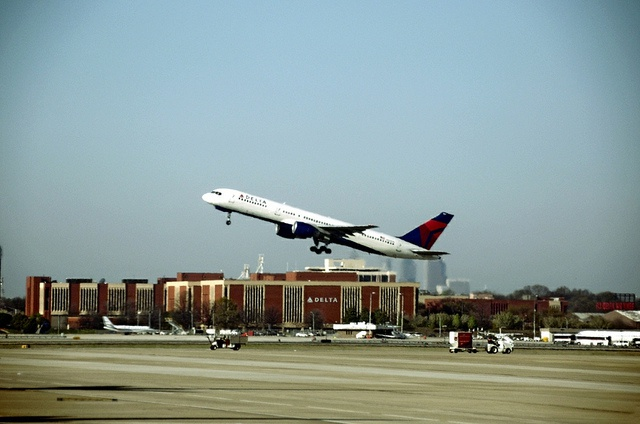Describe the objects in this image and their specific colors. I can see airplane in teal, white, black, darkgray, and gray tones, truck in teal, black, ivory, gray, and darkgray tones, airplane in teal, white, black, gray, and darkgray tones, airplane in teal, white, darkgray, gray, and black tones, and car in teal, ivory, darkgray, gray, and darkgreen tones in this image. 